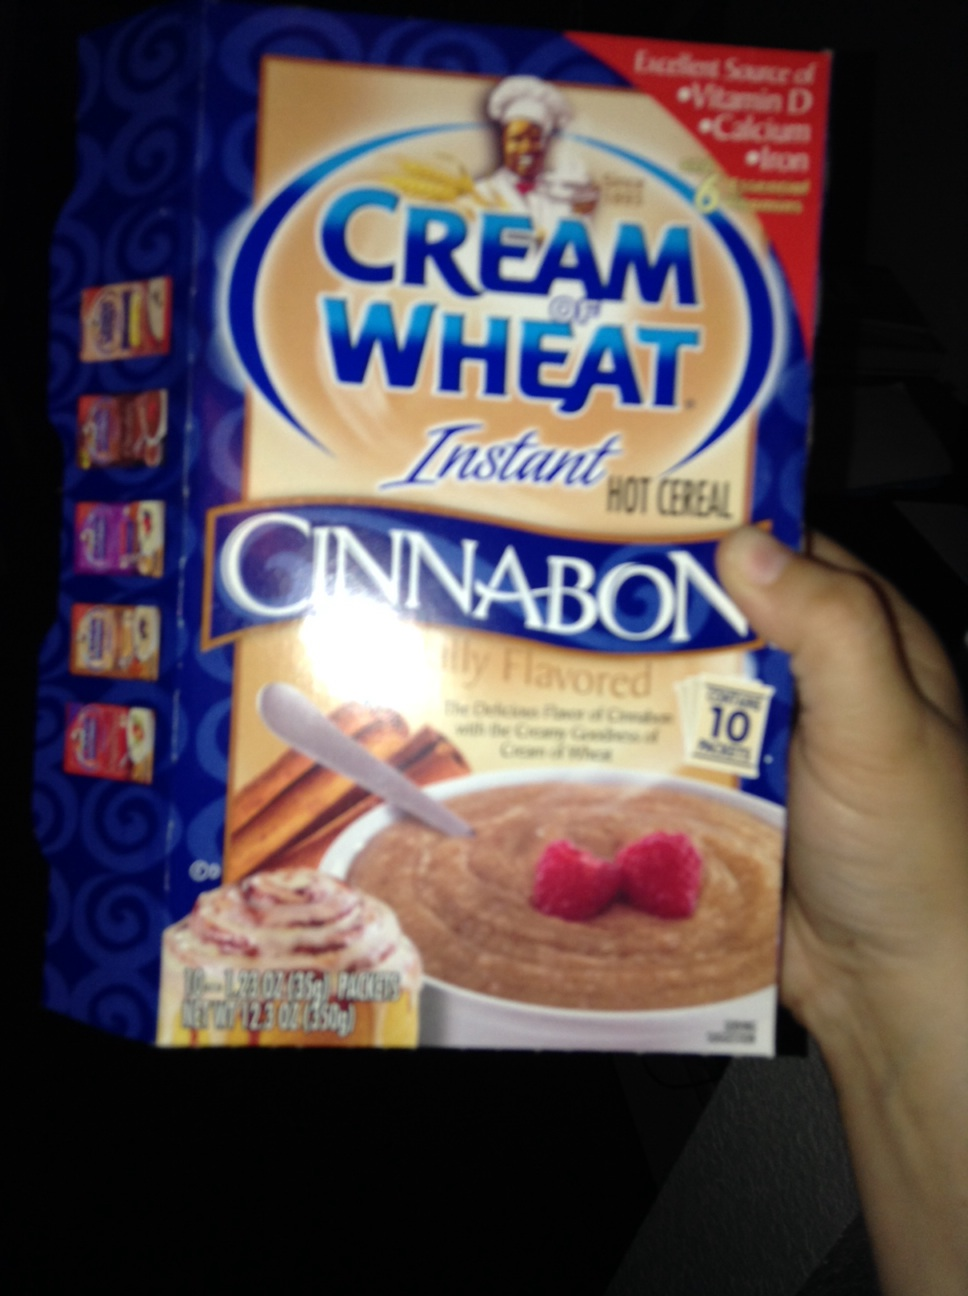Can you explain why Cream of Wheat might be a good breakfast option? Cream of Wheat, especially this Cinnabon flavored version, is not only tasty but also nutritious. It offers essential vitamins and minerals and is a light yet fulfilling option, perfect for starting the day energized. How can I prepare it to enhance its flavor? Consider adding fresh fruits like bananas or berries, a sprinkle of cinnamon, or a dollop of yogurt, which will complement the existing Cinnabon flavors while increasing nutritional value. 